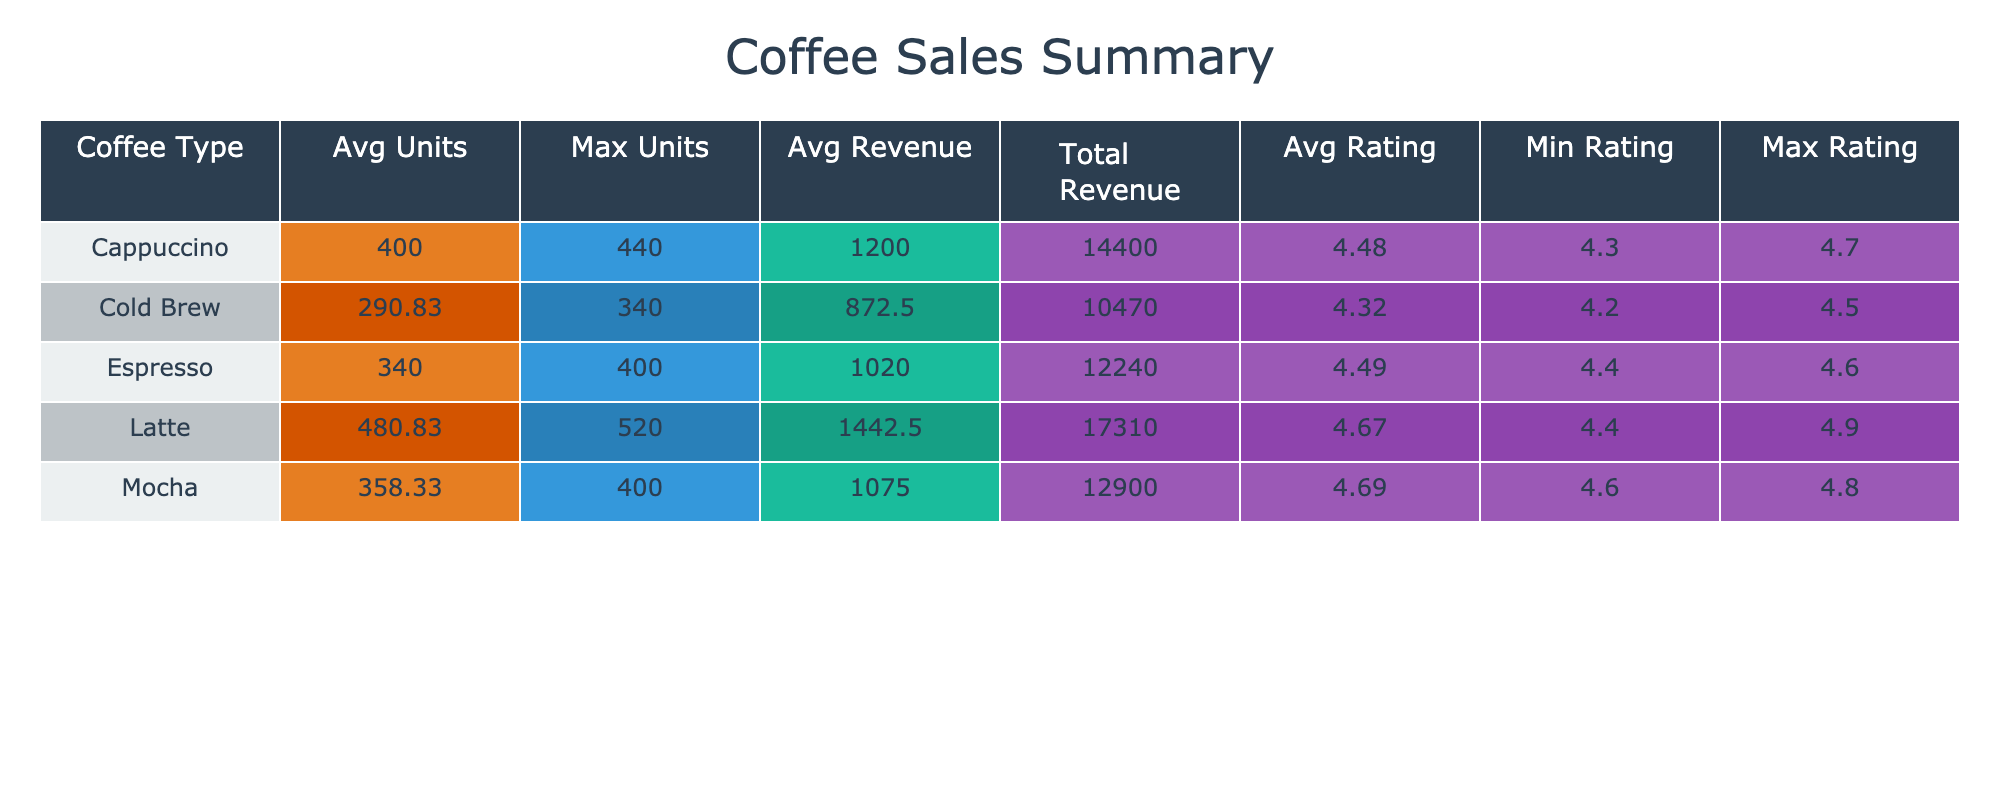What was the coffee type with the highest average unit sold? By examining the "Avg Units" column in the table, we see the highest average unit sold is associated with the Latte, which is 470.
Answer: Latte What is the total revenue generated from Cappuccino sales? To find the total revenue for Cappuccino, we look at the "Total Revenue" column for Cappuccino, which shows $14,970.
Answer: $14,970 Did Espresso have the highest customer rating among all coffee types? The average rating for Espresso shows 4.5, but we see Latte has a higher average rating of 4.6, therefore Espresso does not have the highest rating.
Answer: No What is the difference between the maximum units sold for Latte and Mocha? The maximum units sold for Latte is 520, and for Mocha it is 400. The difference is calculated as 520 - 400 = 120.
Answer: 120 Which coffee type had the lowest average rating, and what was that rating? By checking the "Avg Rating" column, we see that Cold Brew had the lowest average rating of 4.38.
Answer: Cold Brew, 4.38 What is the total revenue generated in January? To calculate the total revenue for January, we add the revenue of all coffee types for that month: 960 + 1350 + 1110 + 750 + 930 = 5100.
Answer: $5,100 Which coffee type had the highest increase in average units sold from January to December? To determine this, we compare the average units sold: January (Espresso 320) and December (Espresso 350); the increase for Espresso is 350 - 320 = 30. Similarly, for other coffee types and find that Latte has the highest increase of 70 (from 450 to 520).
Answer: Latte, 70 Is the average revenue from Mocha greater than the average revenue from Cold Brew? The average revenue for Mocha is $1,080, while Cold Brew is $900. Therefore, Mocha's average revenue is greater than Cold Brew's.
Answer: Yes 